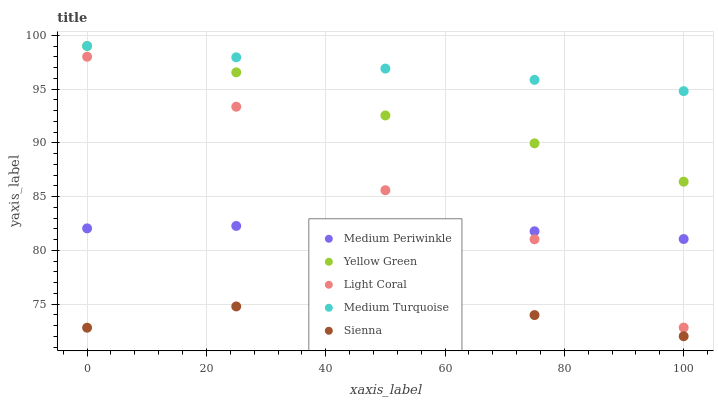Does Sienna have the minimum area under the curve?
Answer yes or no. Yes. Does Medium Turquoise have the maximum area under the curve?
Answer yes or no. Yes. Does Medium Periwinkle have the minimum area under the curve?
Answer yes or no. No. Does Medium Periwinkle have the maximum area under the curve?
Answer yes or no. No. Is Medium Turquoise the smoothest?
Answer yes or no. Yes. Is Light Coral the roughest?
Answer yes or no. Yes. Is Sienna the smoothest?
Answer yes or no. No. Is Sienna the roughest?
Answer yes or no. No. Does Sienna have the lowest value?
Answer yes or no. Yes. Does Medium Periwinkle have the lowest value?
Answer yes or no. No. Does Medium Turquoise have the highest value?
Answer yes or no. Yes. Does Medium Periwinkle have the highest value?
Answer yes or no. No. Is Medium Periwinkle less than Medium Turquoise?
Answer yes or no. Yes. Is Yellow Green greater than Light Coral?
Answer yes or no. Yes. Does Medium Turquoise intersect Yellow Green?
Answer yes or no. Yes. Is Medium Turquoise less than Yellow Green?
Answer yes or no. No. Is Medium Turquoise greater than Yellow Green?
Answer yes or no. No. Does Medium Periwinkle intersect Medium Turquoise?
Answer yes or no. No. 